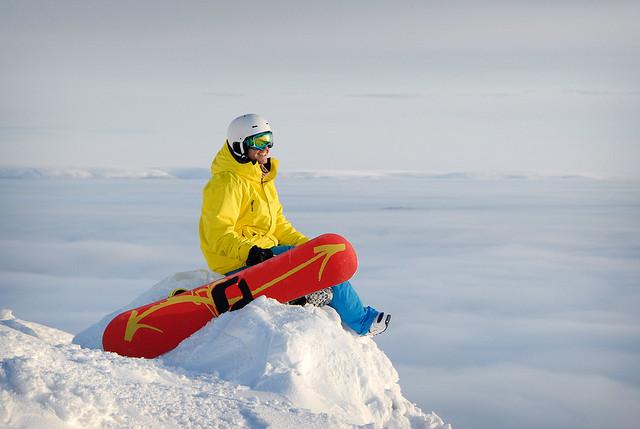Is the person resting?
Write a very short answer. Yes. What is the red thing used for?
Be succinct. Snowboarding. What is the person sitting on?
Keep it brief. Snow. 